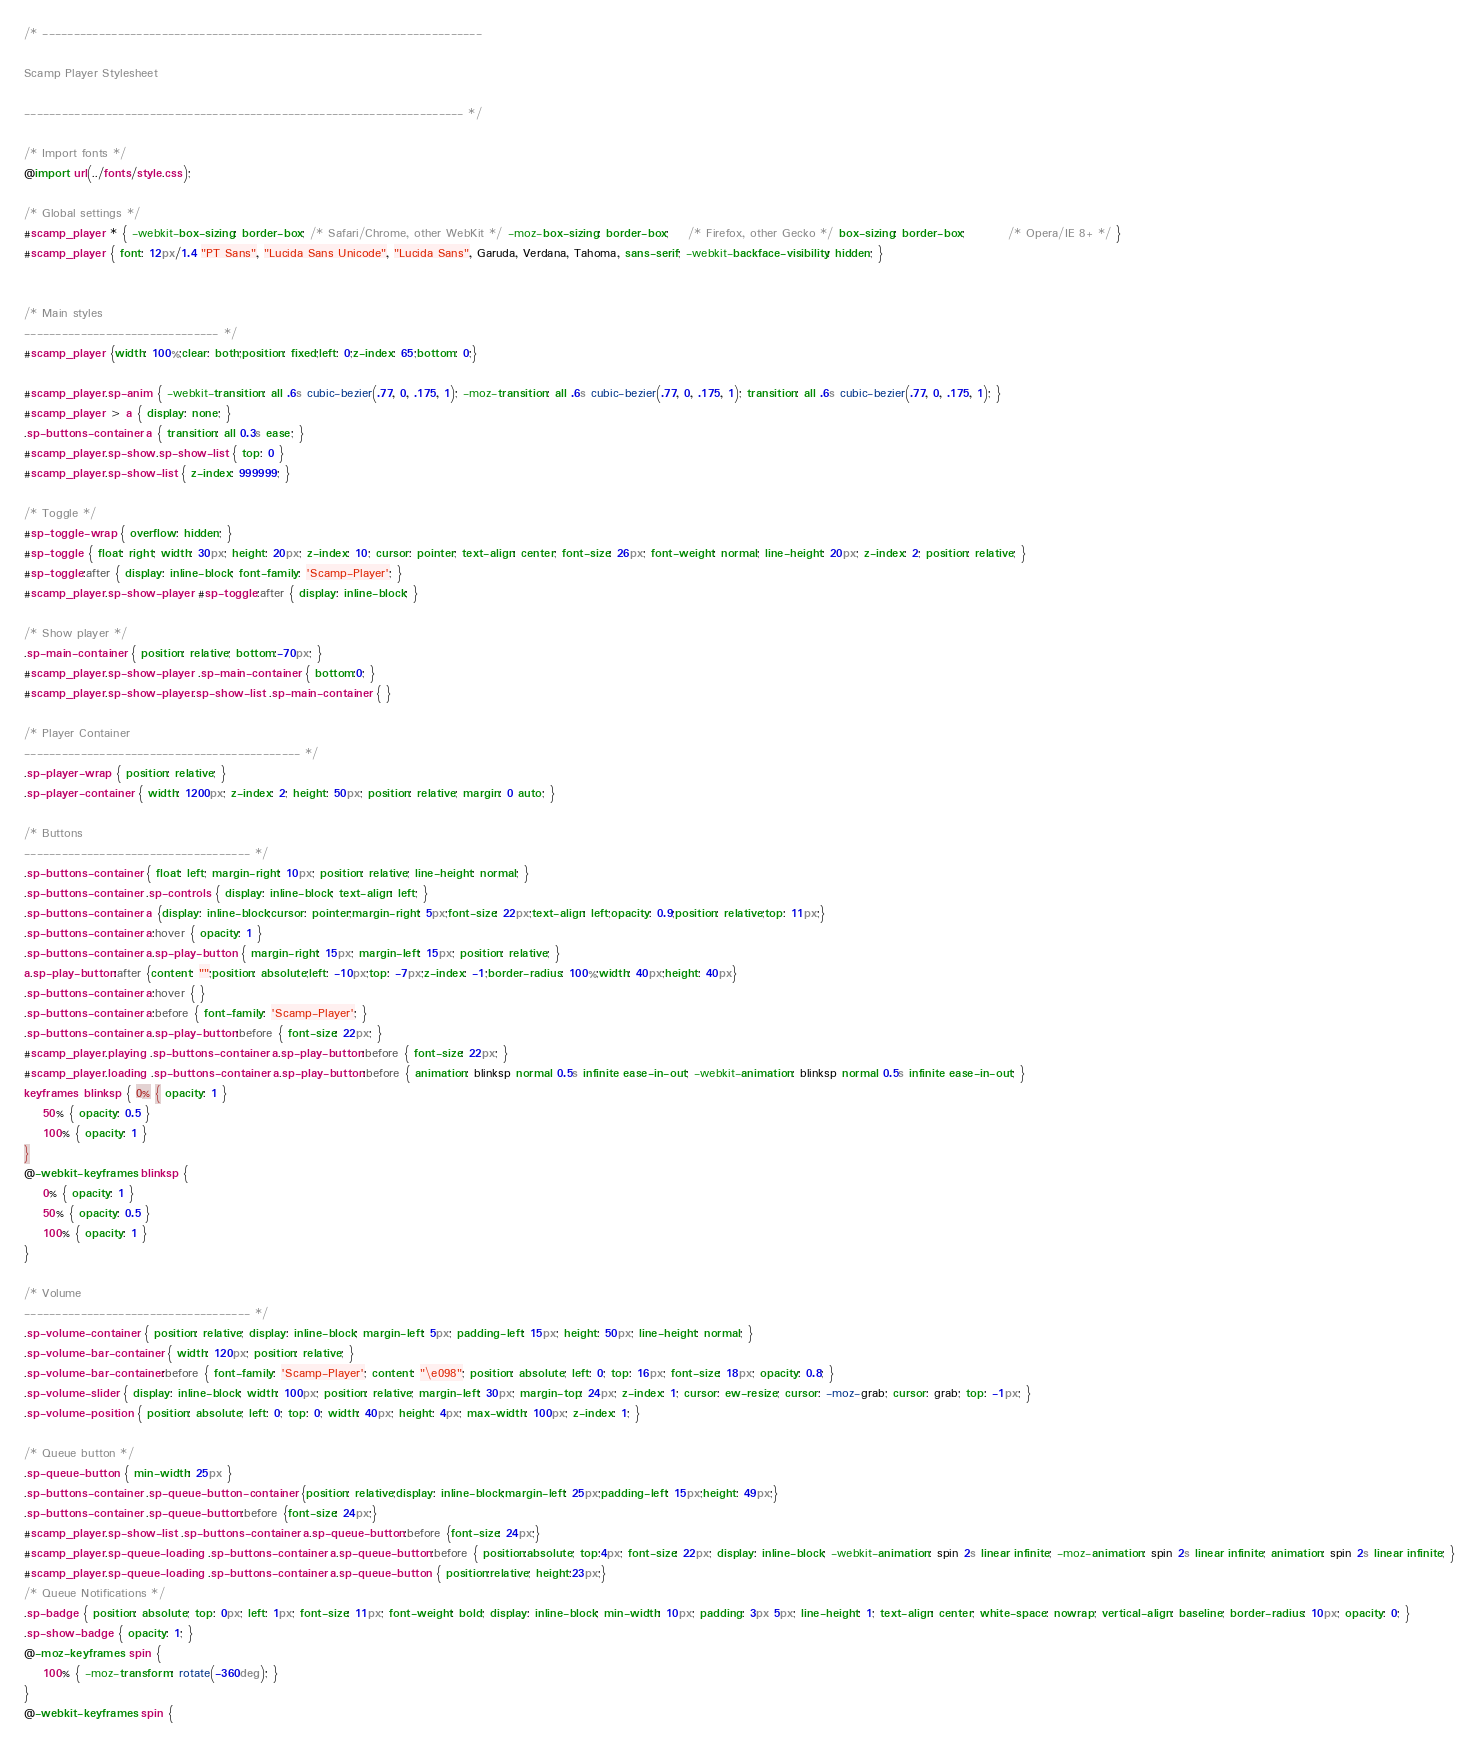Convert code to text. <code><loc_0><loc_0><loc_500><loc_500><_CSS_>/* ----------------------------------------------------------------------

Scamp Player Stylesheet

---------------------------------------------------------------------- */

/* Import fonts */
@import url(../fonts/style.css);

/* Global settings */
#scamp_player * { -webkit-box-sizing: border-box; /* Safari/Chrome, other WebKit */ -moz-box-sizing: border-box;    /* Firefox, other Gecko */ box-sizing: border-box;         /* Opera/IE 8+ */ }
#scamp_player { font: 12px/1.4 "PT Sans", "Lucida Sans Unicode", "Lucida Sans", Garuda, Verdana, Tahoma, sans-serif; -webkit-backface-visibility: hidden; }


/* Main styles
------------------------------- */
#scamp_player {width: 100%;clear: both;position: fixed;left: 0;z-index: 65;bottom: 0;}

#scamp_player.sp-anim { -webkit-transition: all .6s cubic-bezier(.77, 0, .175, 1); -moz-transition: all .6s cubic-bezier(.77, 0, .175, 1); transition: all .6s cubic-bezier(.77, 0, .175, 1); }
#scamp_player > a { display: none; }
.sp-buttons-container a { transition: all 0.3s ease; }
#scamp_player.sp-show.sp-show-list { top: 0 }
#scamp_player.sp-show-list { z-index: 999999; }

/* Toggle */
#sp-toggle-wrap { overflow: hidden; }
#sp-toggle { float: right; width: 30px; height: 20px; z-index: 10; cursor: pointer; text-align: center; font-size: 26px; font-weight: normal; line-height: 20px; z-index: 2; position: relative; }
#sp-toggle:after { display: inline-block; font-family: 'Scamp-Player'; }
#scamp_player.sp-show-player #sp-toggle:after { display: inline-block; }

/* Show player */
.sp-main-container { position: relative; bottom:-70px; }
#scamp_player.sp-show-player .sp-main-container { bottom:0; }
#scamp_player.sp-show-player.sp-show-list .sp-main-container { }

/* Player Container
-------------------------------------------- */
.sp-player-wrap { position: relative; }
.sp-player-container { width: 1200px; z-index: 2; height: 50px; position: relative; margin: 0 auto; }

/* Buttons
------------------------------------ */
.sp-buttons-container { float: left; margin-right: 10px; position: relative; line-height: normal; }
.sp-buttons-container .sp-controls { display: inline-block; text-align: left; }
.sp-buttons-container a {display: inline-block;cursor: pointer;margin-right: 5px;font-size: 22px;text-align: left;opacity: 0.9;position: relative;top: 11px;}
.sp-buttons-container a:hover { opacity: 1 }
.sp-buttons-container a.sp-play-button { margin-right: 15px; margin-left: 15px; position: relative; }
a.sp-play-button:after {content: "";position: absolute;left: -10px;top: -7px;z-index: -1;border-radius: 100%;width: 40px;height: 40px}
.sp-buttons-container a:hover { }
.sp-buttons-container a:before { font-family: 'Scamp-Player'; }
.sp-buttons-container a.sp-play-button:before { font-size: 22px; }
#scamp_player.playing .sp-buttons-container a.sp-play-button:before { font-size: 22px; }
#scamp_player.loading .sp-buttons-container a.sp-play-button:before { animation: blinksp normal 0.5s infinite ease-in-out; -webkit-animation: blinksp normal 0.5s infinite ease-in-out; }
keyframes blinksp { 0% { opacity: 1 }
    50% { opacity: 0.5 }
    100% { opacity: 1 }
}
@-webkit-keyframes blinksp {
    0% { opacity: 1 }
    50% { opacity: 0.5 }
    100% { opacity: 1 }
}

/* Volume
------------------------------------ */
.sp-volume-container { position: relative; display: inline-block; margin-left: 5px; padding-left: 15px; height: 50px; line-height: normal; }
.sp-volume-bar-container { width: 120px; position: relative; }
.sp-volume-bar-container:before { font-family: 'Scamp-Player'; content: "\e098"; position: absolute; left: 0; top: 16px; font-size: 18px; opacity: 0.8; }
.sp-volume-slider { display: inline-block; width: 100px; position: relative; margin-left: 30px; margin-top: 24px; z-index: 1; cursor: ew-resize; cursor: -moz-grab; cursor: grab; top: -1px; }
.sp-volume-position { position: absolute; left: 0; top: 0; width: 40px; height: 4px; max-width: 100px; z-index: 1; }

/* Queue button */
.sp-queue-button { min-width: 25px }
.sp-buttons-container .sp-queue-button-container {position: relative;display: inline-block;margin-left: 25px;padding-left: 15px;height: 49px;}
.sp-buttons-container .sp-queue-button:before {font-size: 24px;}
#scamp_player.sp-show-list .sp-buttons-container a.sp-queue-button:before {font-size: 24px;}
#scamp_player.sp-queue-loading .sp-buttons-container a.sp-queue-button:before { position:absolute; top:4px; font-size: 22px; display: inline-block; -webkit-animation: spin 2s linear infinite; -moz-animation: spin 2s linear infinite; animation: spin 2s linear infinite; }
#scamp_player.sp-queue-loading .sp-buttons-container a.sp-queue-button { position:relative; height:23px;}
/* Queue Notifications */
.sp-badge { position: absolute; top: 0px; left: 1px; font-size: 11px; font-weight: bold; display: inline-block; min-width: 10px; padding: 3px 5px; line-height: 1; text-align: center; white-space: nowrap; vertical-align: baseline; border-radius: 10px; opacity: 0; }
.sp-show-badge { opacity: 1; }
@-moz-keyframes spin {
    100% { -moz-transform: rotate(-360deg); }
}
@-webkit-keyframes spin {</code> 